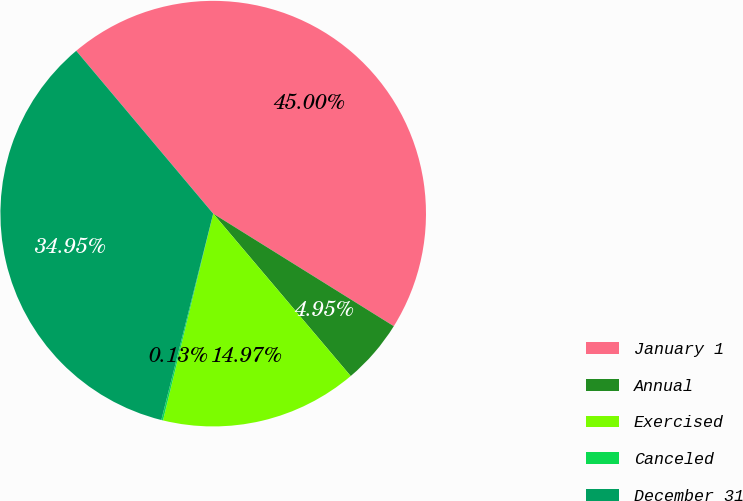Convert chart. <chart><loc_0><loc_0><loc_500><loc_500><pie_chart><fcel>January 1<fcel>Annual<fcel>Exercised<fcel>Canceled<fcel>December 31<nl><fcel>45.0%<fcel>4.95%<fcel>14.97%<fcel>0.13%<fcel>34.95%<nl></chart> 